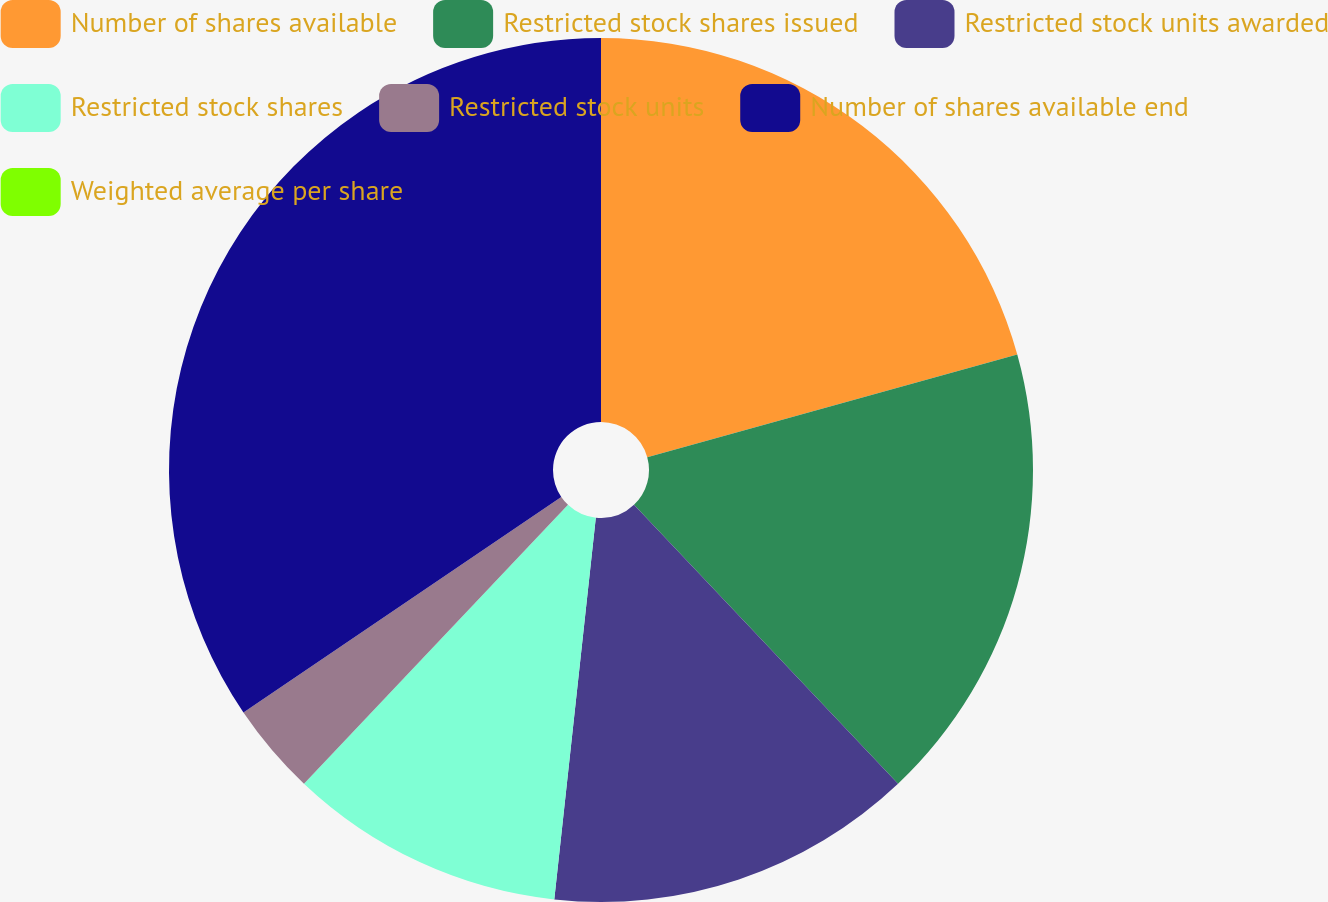Convert chart. <chart><loc_0><loc_0><loc_500><loc_500><pie_chart><fcel>Number of shares available<fcel>Restricted stock shares issued<fcel>Restricted stock units awarded<fcel>Restricted stock shares<fcel>Restricted stock units<fcel>Number of shares available end<fcel>Weighted average per share<nl><fcel>20.69%<fcel>17.24%<fcel>13.79%<fcel>10.34%<fcel>3.45%<fcel>34.48%<fcel>0.0%<nl></chart> 